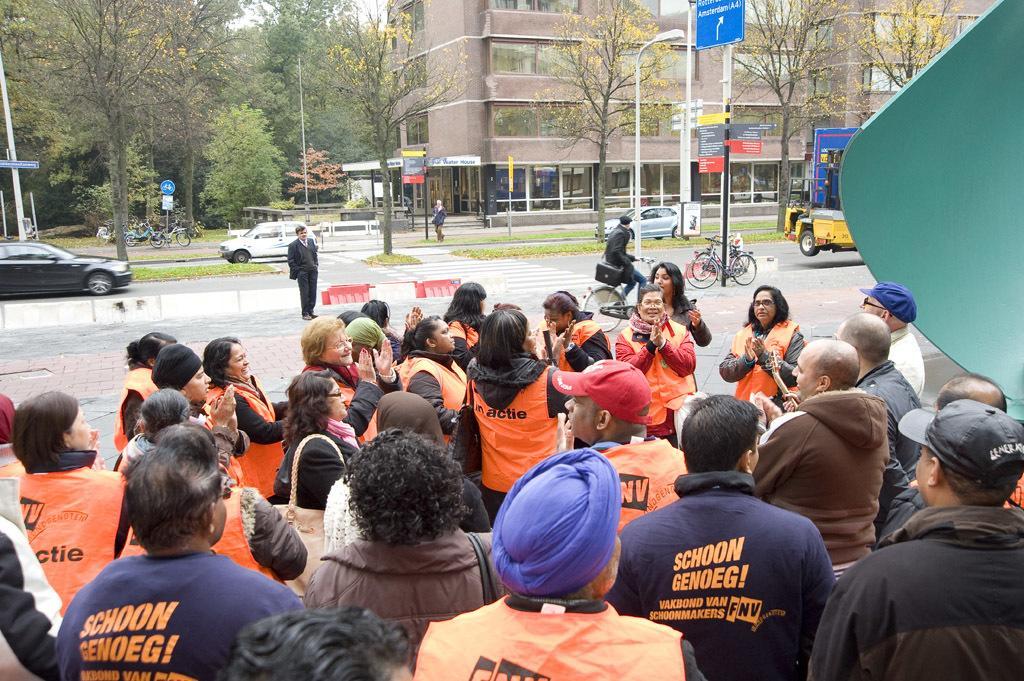Could you give a brief overview of what you see in this image? In this image I can see group of people some are sitting and some are standing. The person in front orange color jacket, background I can see few persons some are riding vehicles, few buildings in brown color, trees in green color and sky is in white color. 